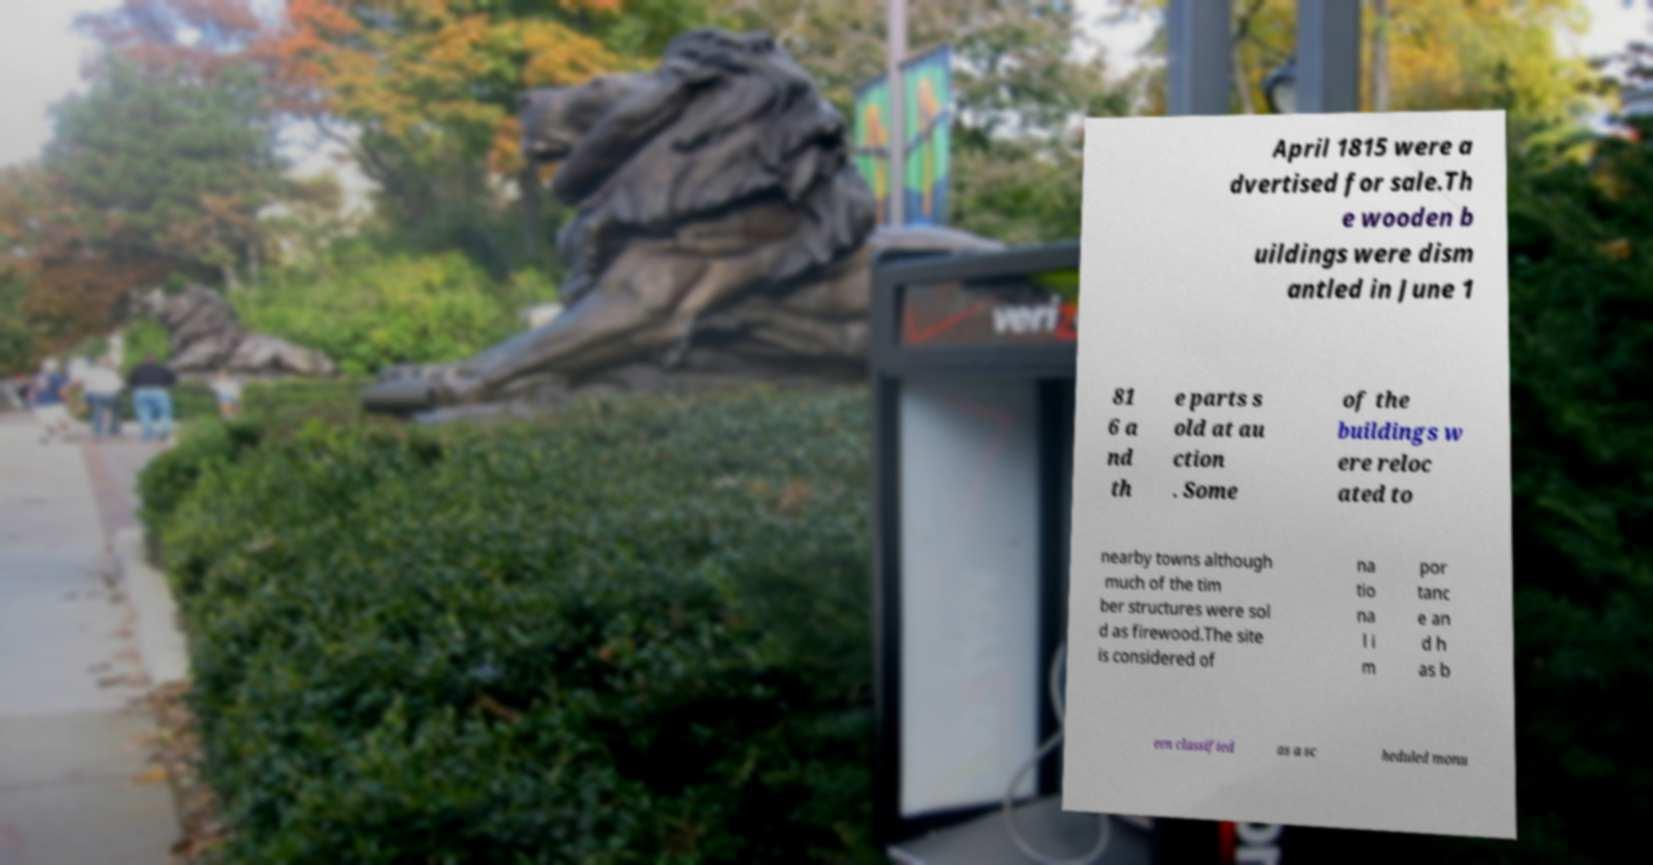What messages or text are displayed in this image? I need them in a readable, typed format. April 1815 were a dvertised for sale.Th e wooden b uildings were dism antled in June 1 81 6 a nd th e parts s old at au ction . Some of the buildings w ere reloc ated to nearby towns although much of the tim ber structures were sol d as firewood.The site is considered of na tio na l i m por tanc e an d h as b een classified as a sc heduled monu 